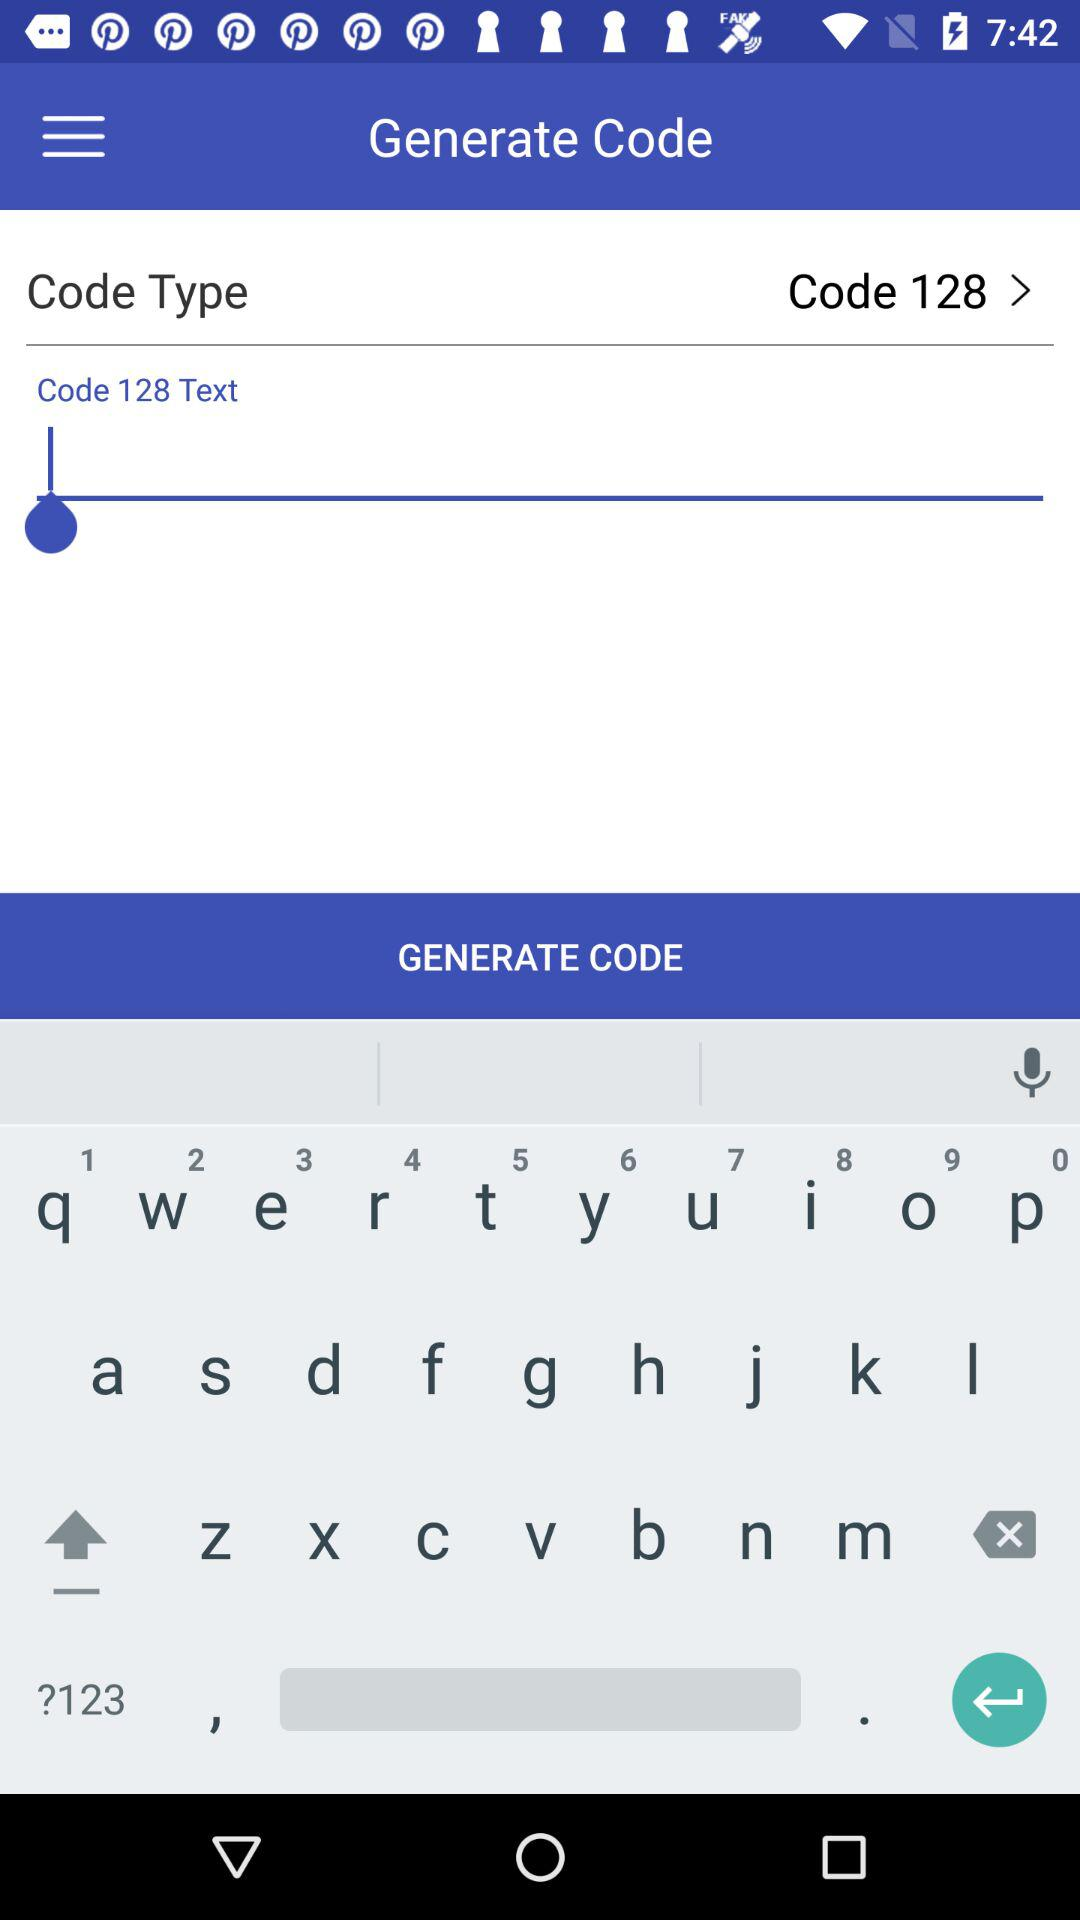What is the application name? The application name is "Barcode Scanner". 